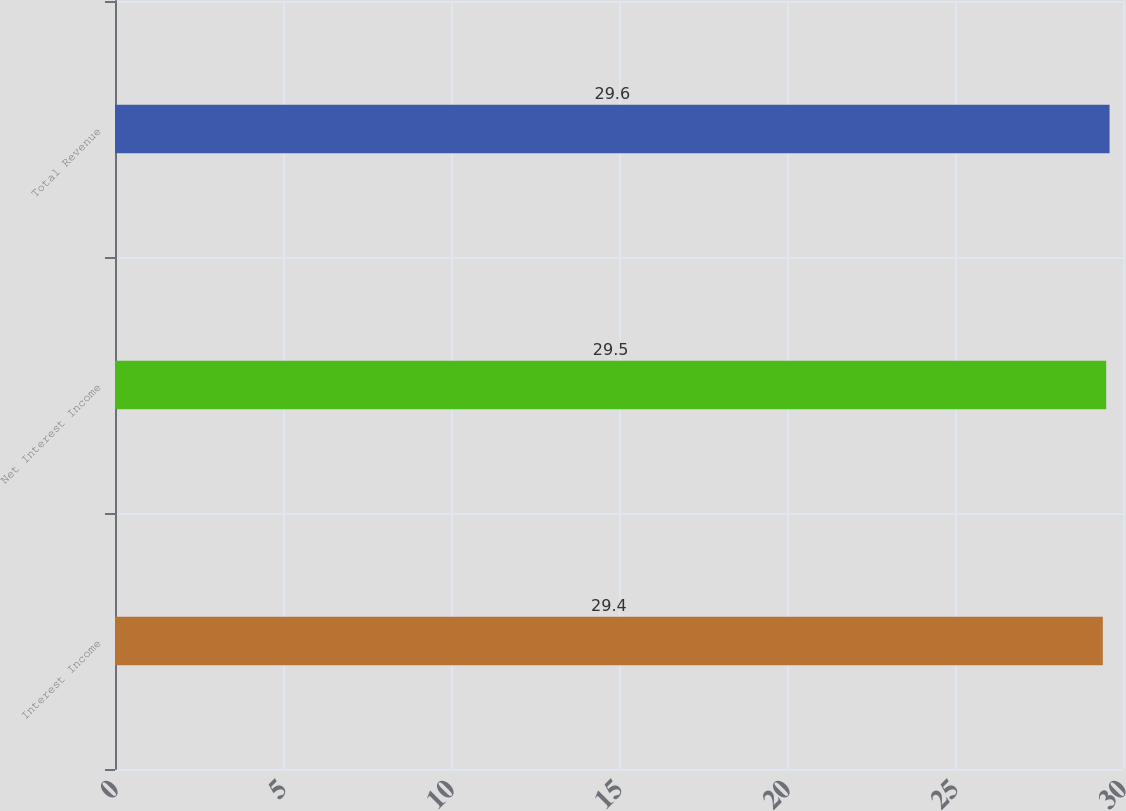Convert chart. <chart><loc_0><loc_0><loc_500><loc_500><bar_chart><fcel>Interest Income<fcel>Net Interest Income<fcel>Total Revenue<nl><fcel>29.4<fcel>29.5<fcel>29.6<nl></chart> 